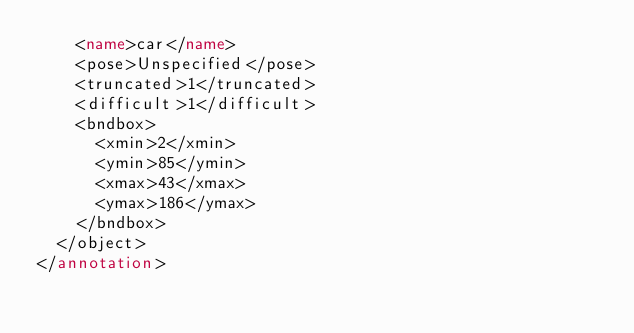Convert code to text. <code><loc_0><loc_0><loc_500><loc_500><_XML_>		<name>car</name>
		<pose>Unspecified</pose>
		<truncated>1</truncated>
		<difficult>1</difficult>
		<bndbox>
			<xmin>2</xmin>
			<ymin>85</ymin>
			<xmax>43</xmax>
			<ymax>186</ymax>
		</bndbox>
	</object>
</annotation>
</code> 